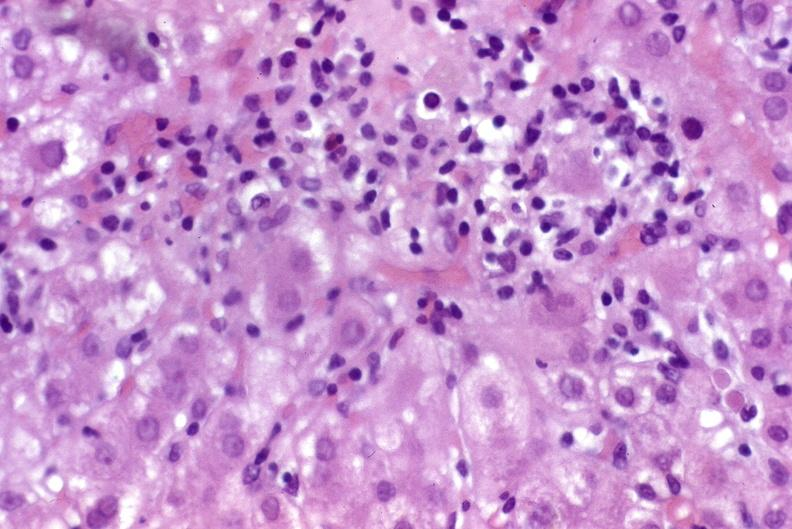what does this image show?
Answer the question using a single word or phrase. Recurrent hepatitis c virus 